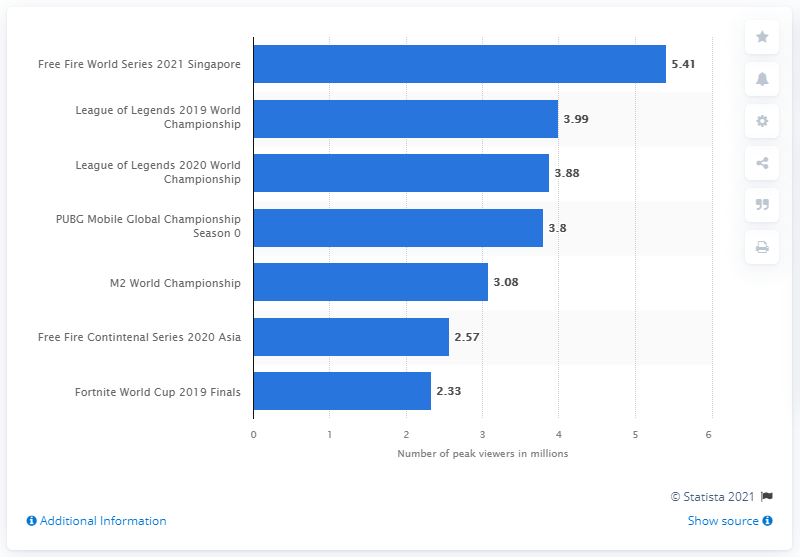Mention a couple of crucial points in this snapshot. A total of 3.99 billion individuals tuned in to watch the 2019 League of Legends World Championship. 